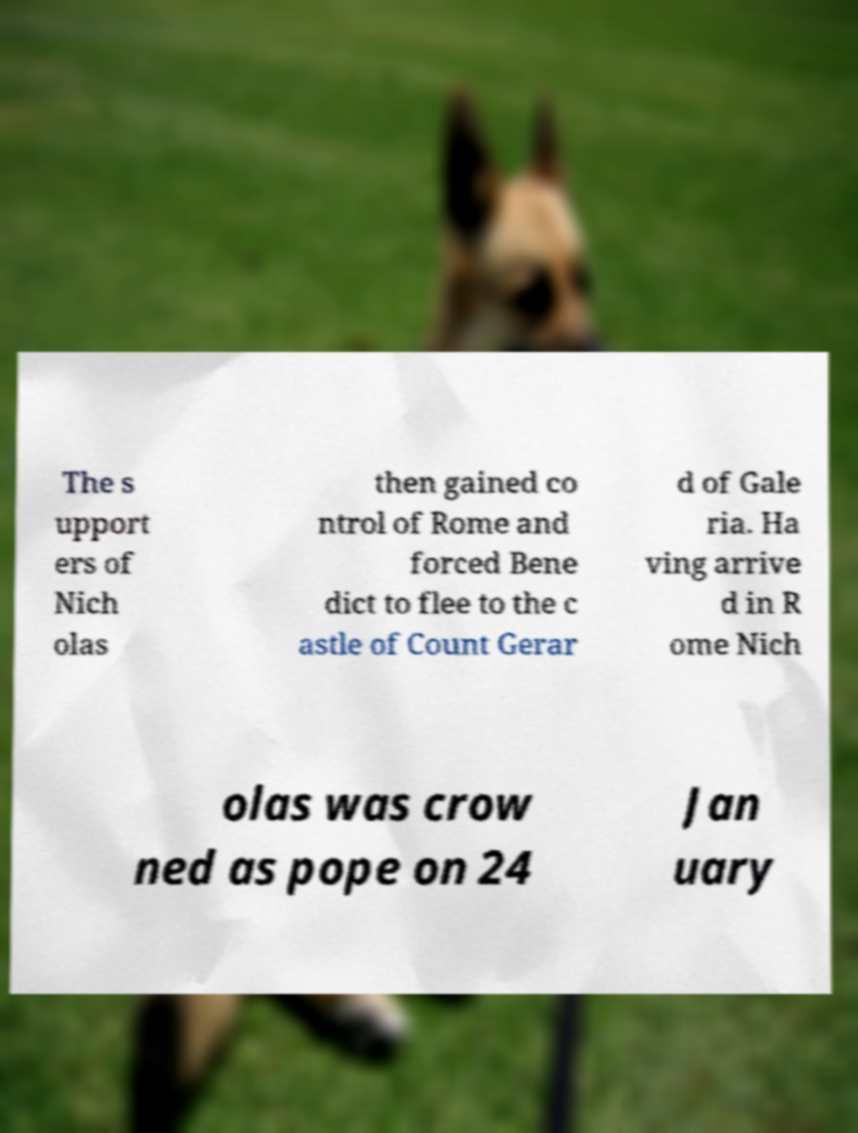For documentation purposes, I need the text within this image transcribed. Could you provide that? The s upport ers of Nich olas then gained co ntrol of Rome and forced Bene dict to flee to the c astle of Count Gerar d of Gale ria. Ha ving arrive d in R ome Nich olas was crow ned as pope on 24 Jan uary 